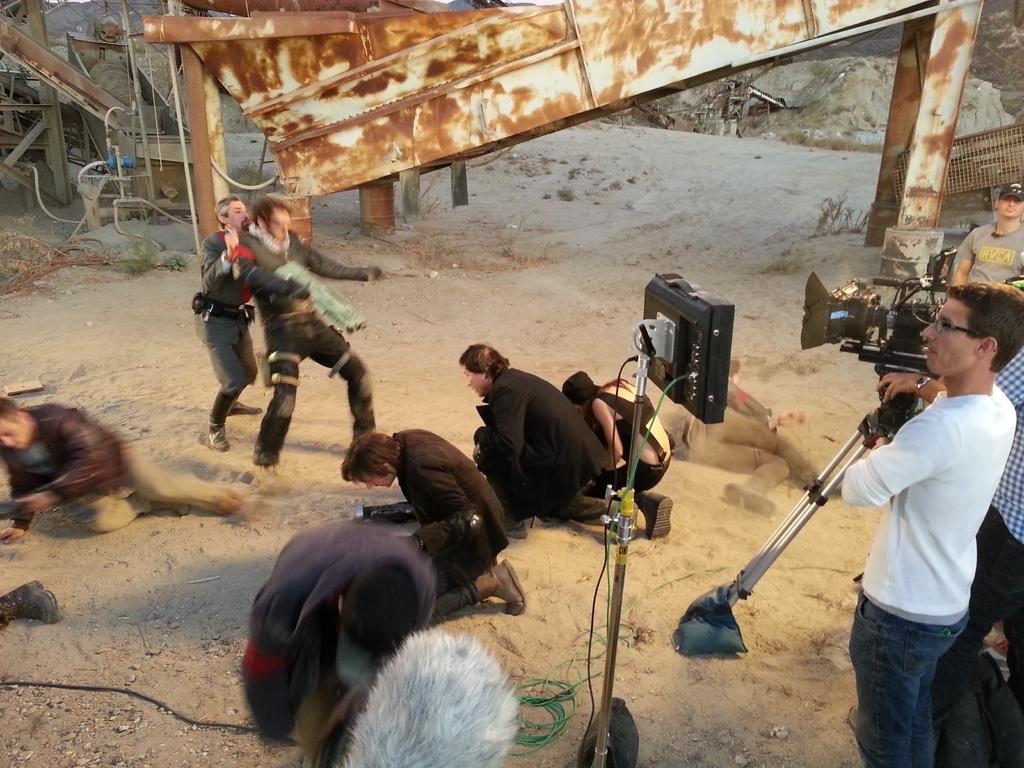Can you describe this image briefly? In this picture there are three people standing and there is a person standing and holding the camera. In the foreground there is a man standing and there is an object. At the back there are group of people on the ground and there are two people standing and there might be fighting and there are metal objects and there are plants. At the bottom there are wires on the ground. 